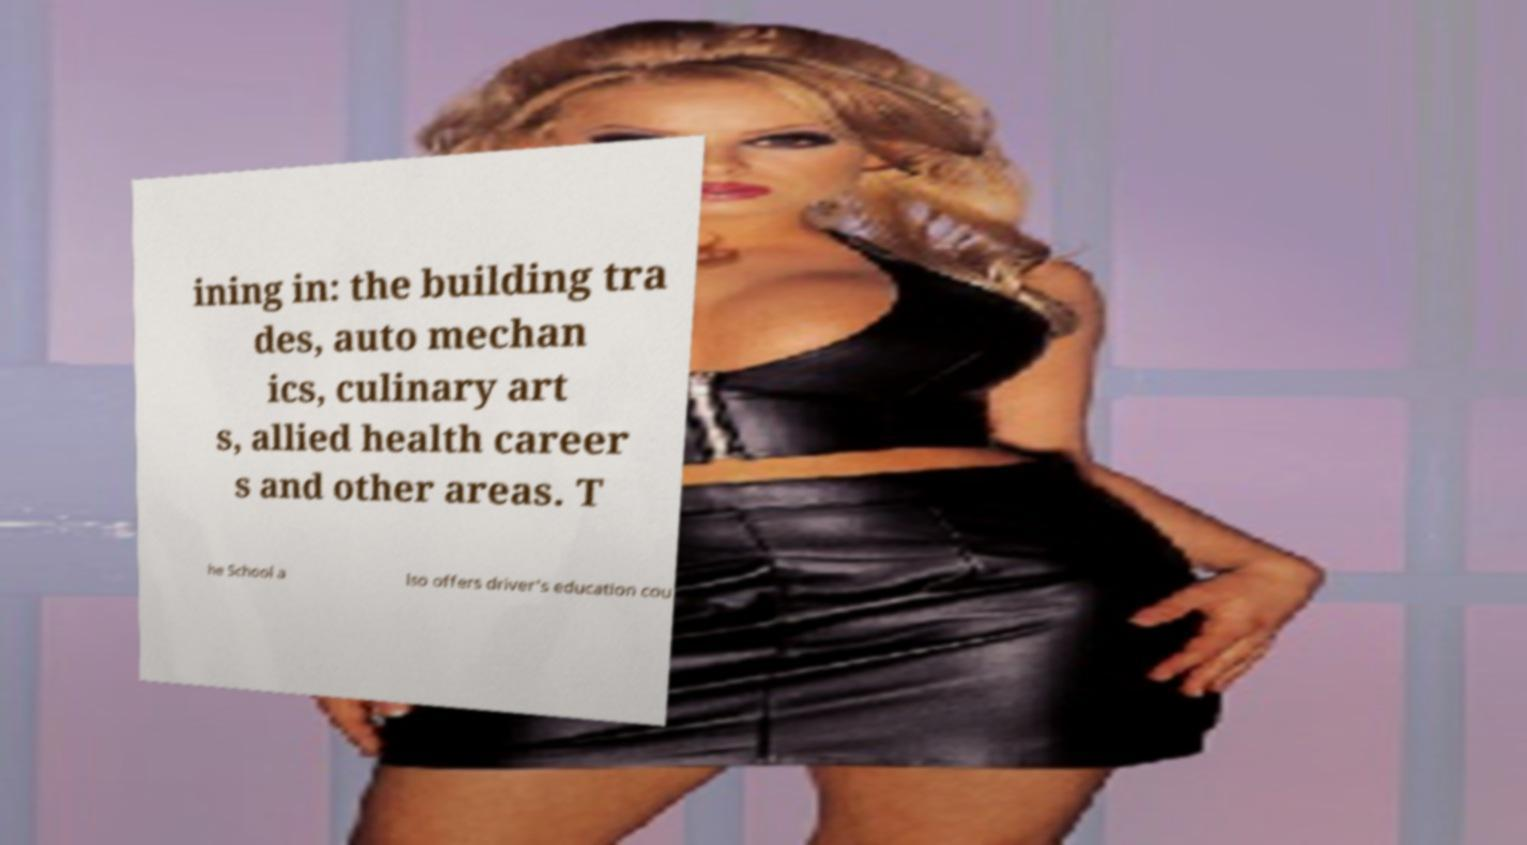Could you assist in decoding the text presented in this image and type it out clearly? ining in: the building tra des, auto mechan ics, culinary art s, allied health career s and other areas. T he School a lso offers driver's education cou 